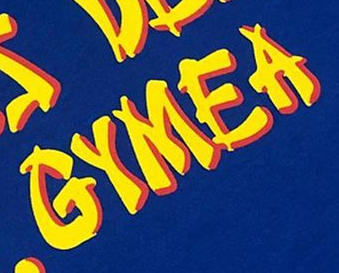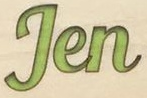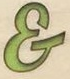Identify the words shown in these images in order, separated by a semicolon. GYMEA; Jen; & 